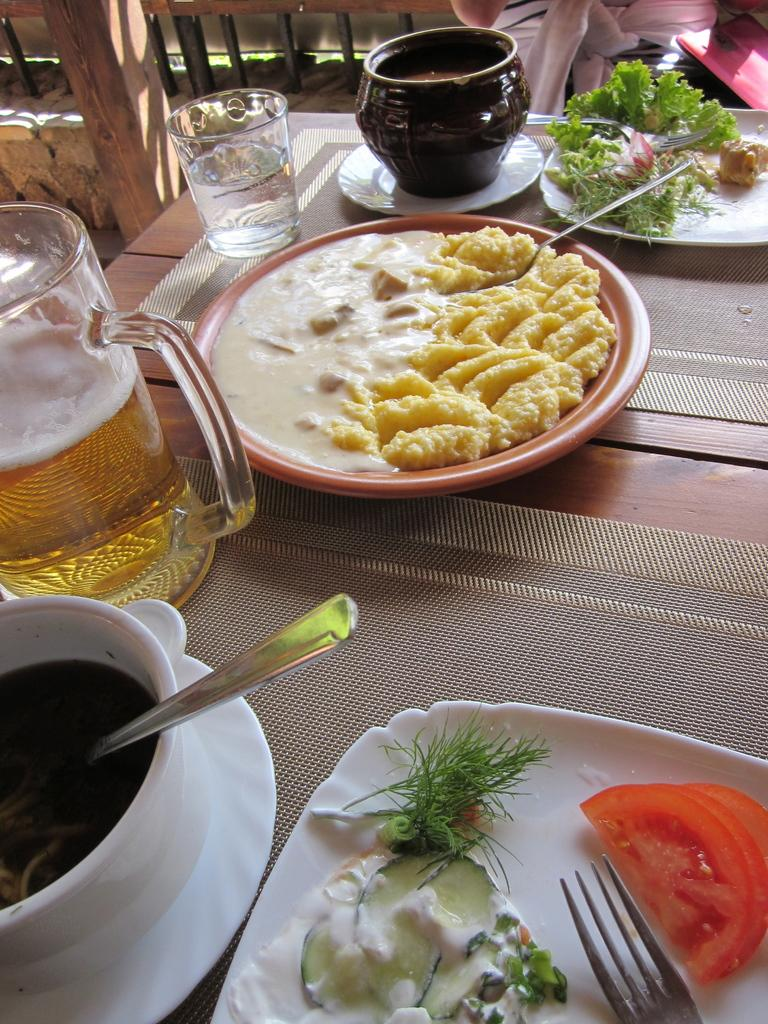What is on the plate in the image? There is food in a plate in the image. What utensils are on the table in the image? There is a spoon, a glass, a bowl, a jug, and a fork on the table in the image. What type of patch is being discussed by the governor in the image? There is no governor or patch present in the image. 